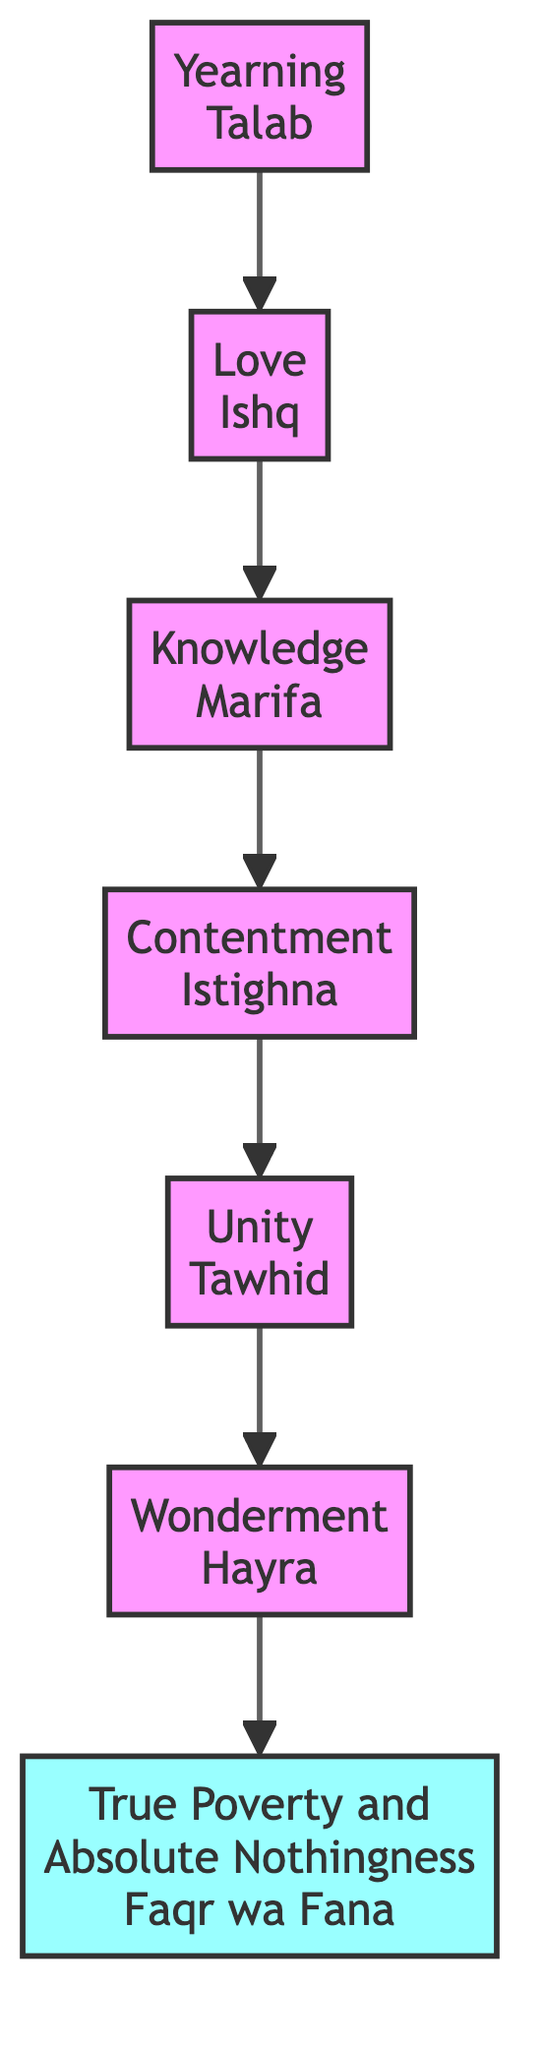What is the first valley in the journey? The flow chart begins with the first node named "Yearning (Talab)", representing the initial state of the seeker.
Answer: Yearning (Talab) How many valleys are represented in the diagram? The diagram clearly shows a total of seven nodes, each representing a valley in the journey through Sufism, from Yearning to True Poverty and Absolute Nothingness.
Answer: 7 What follows Love (Ishq) in the sequence? Following Love (Ishq), the next node in the flow is Knowledge (Marifa), connected directly through an arrow indicating the progression.
Answer: Knowledge (Marifa) Which valley indicates the realization of unity in existence? The node labeled Unity (Tawhid) signifies the valley where the seeker perceives the interconnectedness of all existence within the divine essence.
Answer: Unity (Tawhid) What is the last valley in this journey? The sequence ends with the last node titled True Poverty and Absolute Nothingness (Faqr wa Fana), which does not connect to any further nodes, indicating completion.
Answer: True Poverty and Absolute Nothingness (Faqr wa Fana) Describe the relationship between Knowledge (Marifa) and Contentment (Istighna). Knowledge (Marifa) is directly connected to Contentment (Istighna) as the subsequent step in the journey, indicating that the seeker acquires knowledge before achieving contentment.
Answer: Knowledge (Marifa) → Contentment (Istighna) What state does a seeker reach after experiencing Wonderment (Hayra)? After reaching Wonderment (Hayra), the seeker progresses to the final valley, True Poverty and Absolute Nothingness (Faqr wa Fana), completing their spiritual journey.
Answer: True Poverty and Absolute Nothingness (Faqr wa Fana) Which valley signifies a state of undisturbed worldly desires? The valley represented by Contentment (Istighna) signifies a state where the seeker becomes undisturbed by worldly desires, realizing the sufficiency of the Divine.
Answer: Contentment (Istighna) 